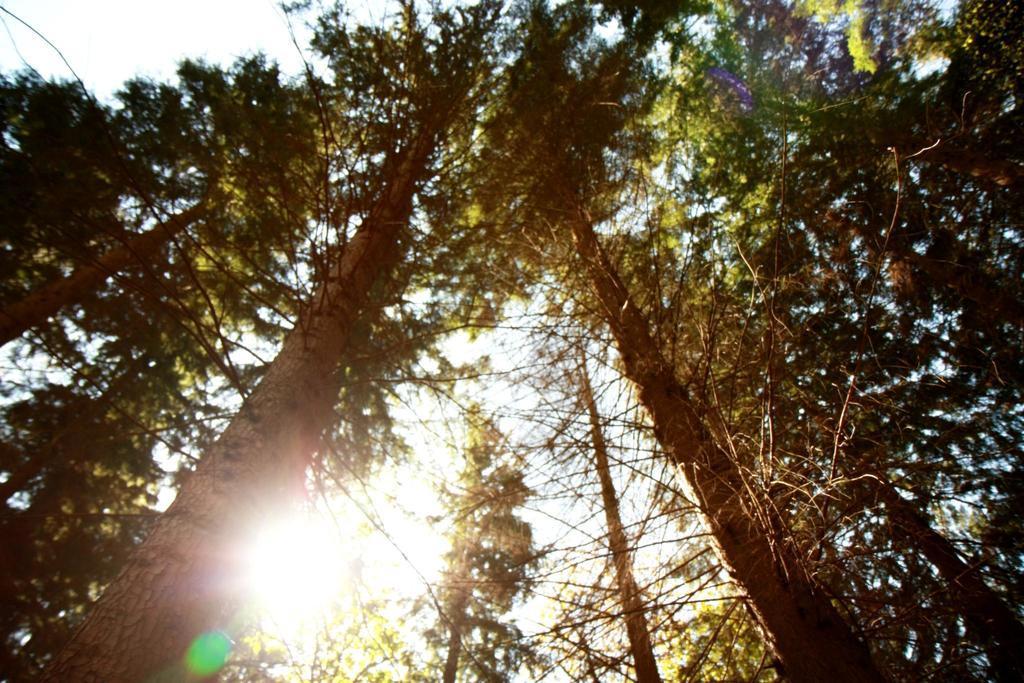Could you give a brief overview of what you see in this image? In this image we can see sky and trees. 